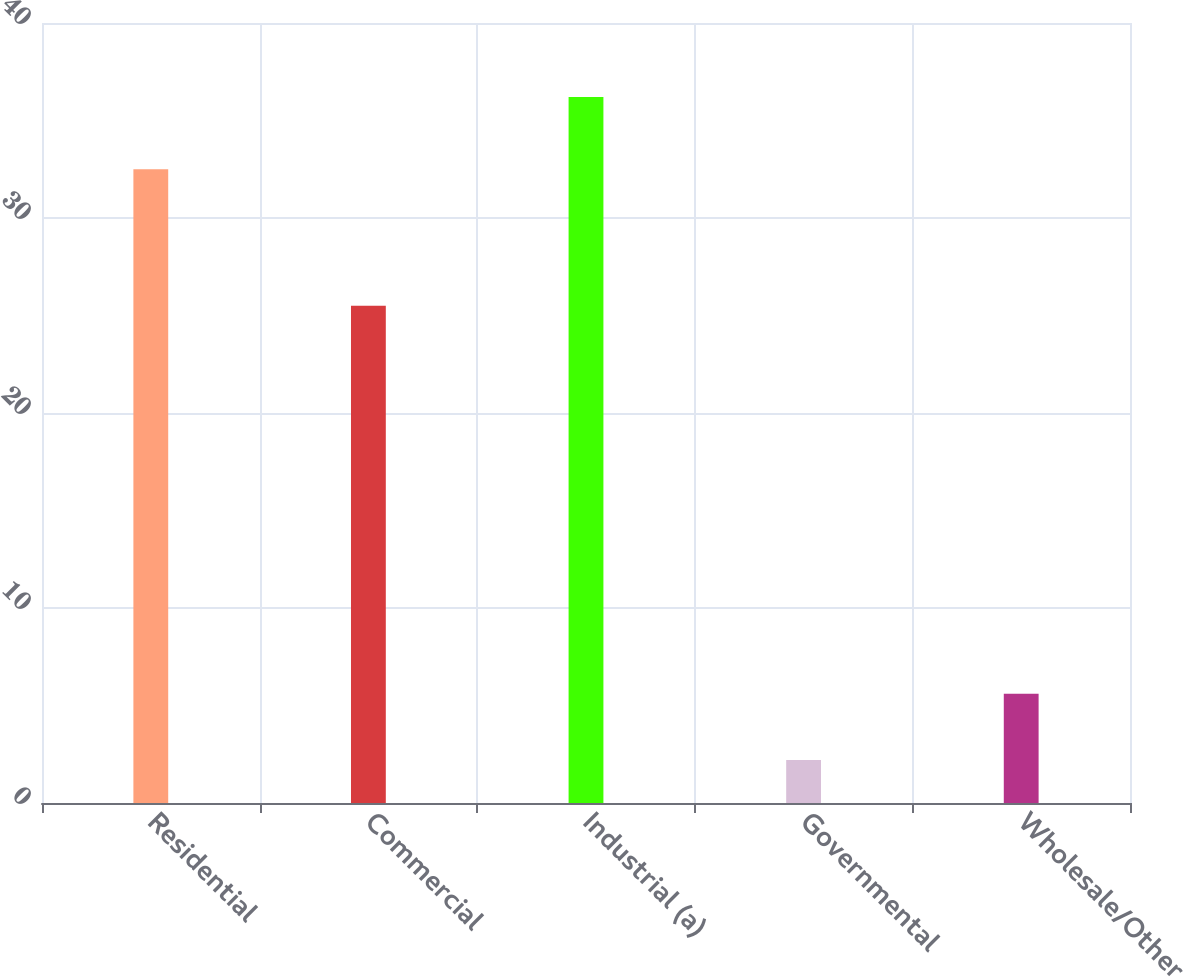<chart> <loc_0><loc_0><loc_500><loc_500><bar_chart><fcel>Residential<fcel>Commercial<fcel>Industrial (a)<fcel>Governmental<fcel>Wholesale/Other<nl><fcel>32.5<fcel>25.5<fcel>36.2<fcel>2.2<fcel>5.6<nl></chart> 